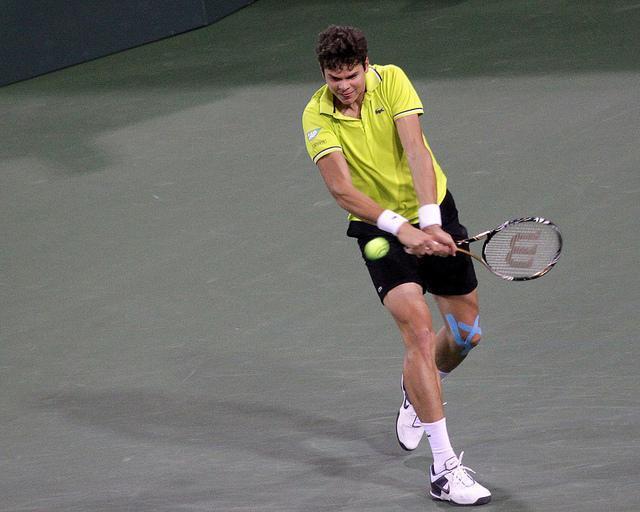How many shadows are present?
Give a very brief answer. 2. 